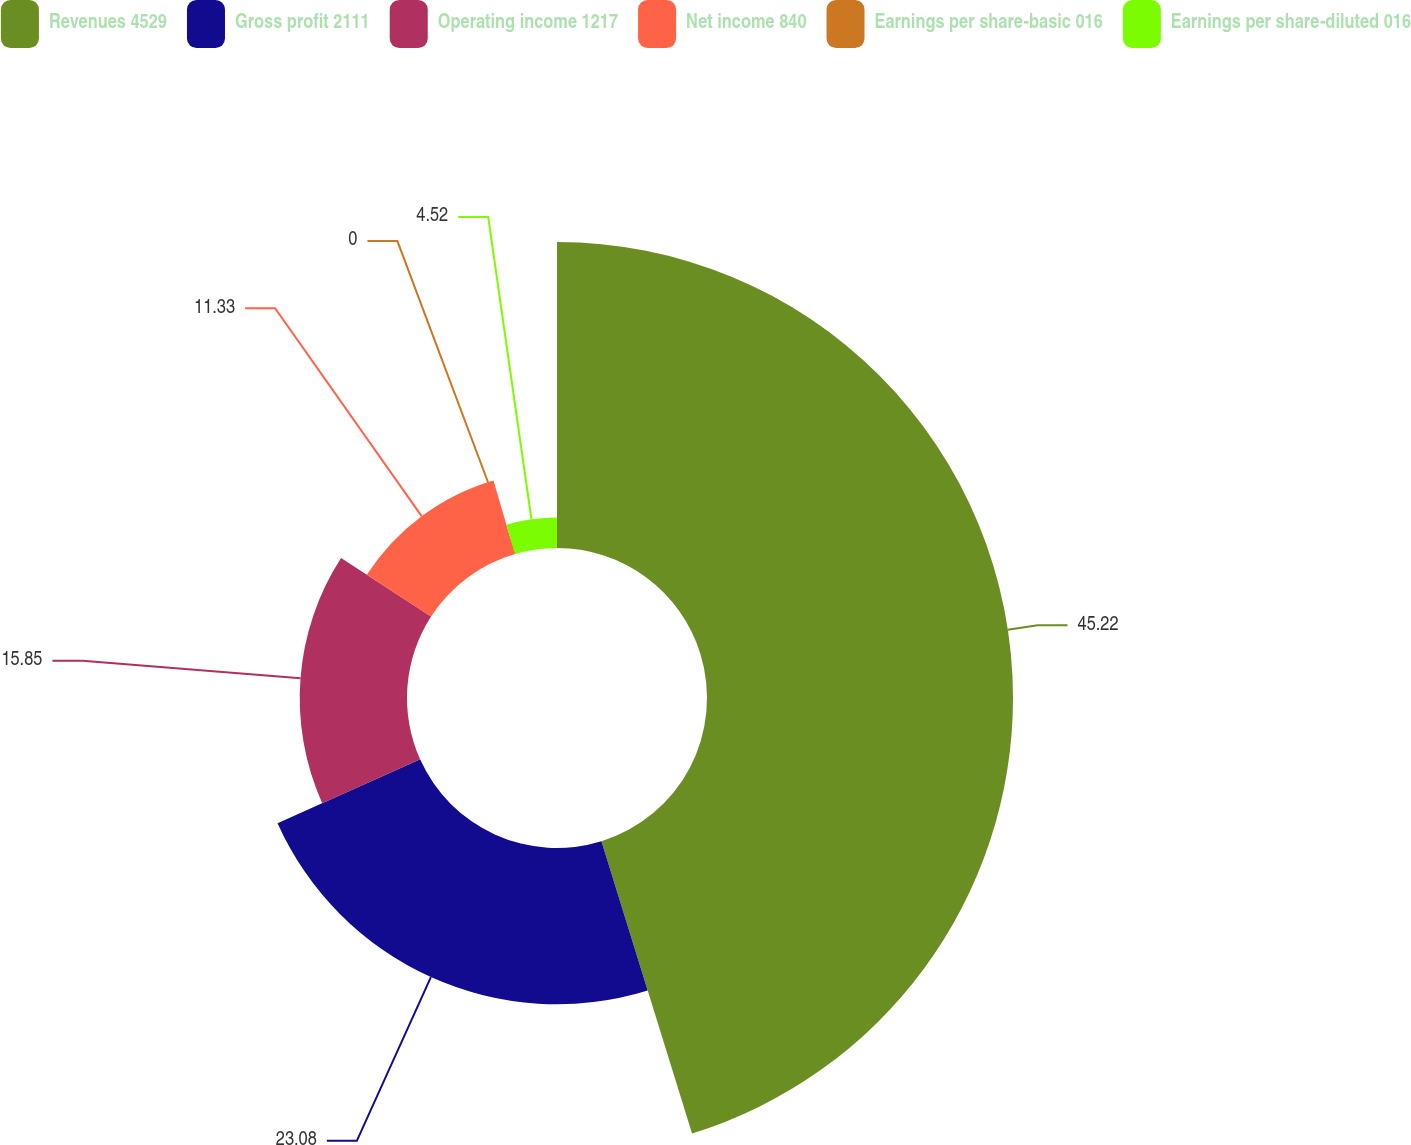Convert chart to OTSL. <chart><loc_0><loc_0><loc_500><loc_500><pie_chart><fcel>Revenues 4529<fcel>Gross profit 2111<fcel>Operating income 1217<fcel>Net income 840<fcel>Earnings per share-basic 016<fcel>Earnings per share-diluted 016<nl><fcel>45.21%<fcel>23.08%<fcel>15.85%<fcel>11.33%<fcel>0.0%<fcel>4.52%<nl></chart> 